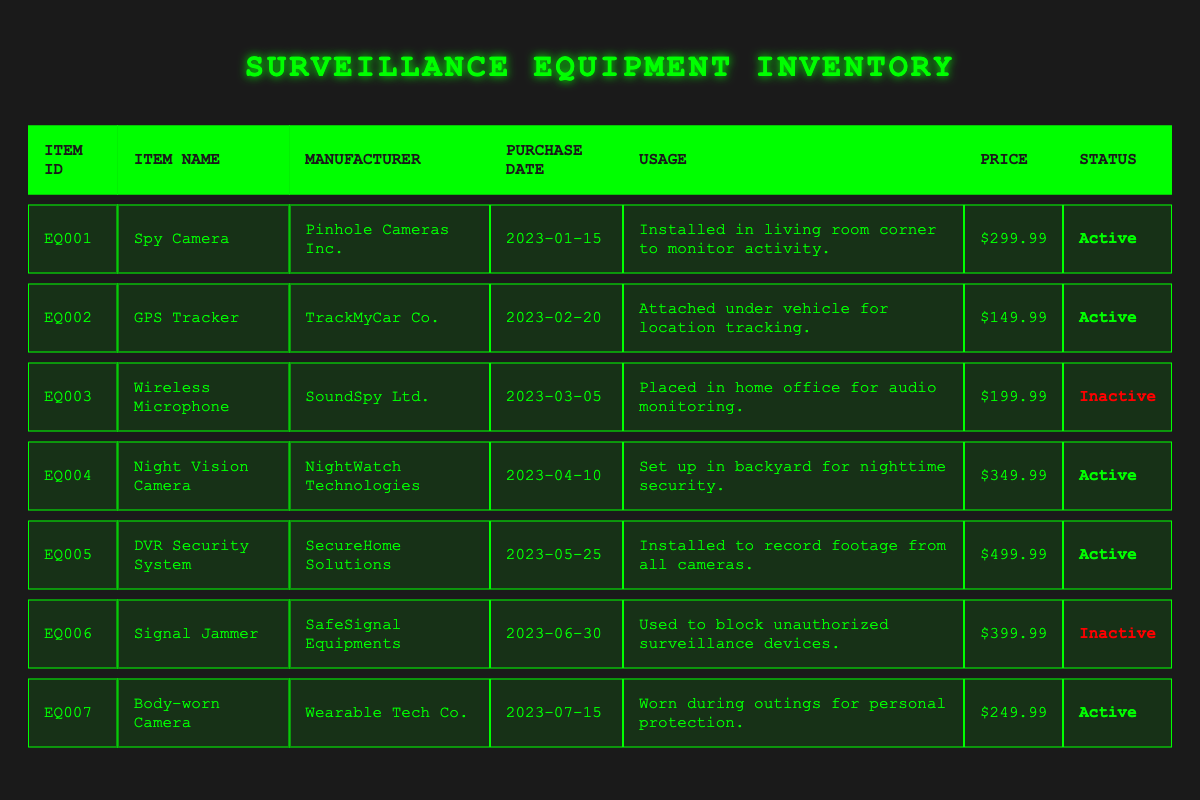What is the total number of active surveillance equipment items? By looking at the status column, we can see that the active items are: Spy Camera, GPS Tracker, Night Vision Camera, DVR Security System, and Body-worn Camera. There are 5 items in total that are marked as active.
Answer: 5 Which item is the most expensive and what is its price? The prices for each item are: Spy Camera ($299.99), GPS Tracker ($149.99), Wireless Microphone ($199.99), Night Vision Camera ($349.99), DVR Security System ($499.99), Signal Jammer ($399.99), and Body-worn Camera ($249.99). The DVR Security System has the highest price of $499.99.
Answer: DVR Security System, $499.99 Is the Wireless Microphone currently active? The status column shows that the Wireless Microphone is labeled as inactive.
Answer: No What is the average price of all surveillance equipment? The prices of the items are: $299.99, $149.99, $199.99, $349.99, $499.99, $399.99, and $249.99. Summing these gives a total of $2149.94, and dividing by the number of items (7) gives an average price of approximately $307.13.
Answer: $307.13 Are all items purchased from different manufacturers? Reviewing the manufacturers: Pinhole Cameras Inc., TrackMyCar Co., SoundSpy Ltd., NightWatch Technologies, SecureHome Solutions, SafeSignal Equipments, and Wearable Tech Co., we see that all items have unique manufacturers with no duplicates.
Answer: Yes Which piece of equipment has multiple uses listed in the table? Looking through the usage descriptions, each item has only one specific use listed, such as monitoring, tracking, or protecting. Therefore, none of the items have multiple uses mentioned in the table.
Answer: None How many items were purchased after April 2023? Checking the purchase dates, the items purchased after April 2023 are the DVR Security System (May 25, 2023), Signal Jammer (June 30, 2023), and Body-worn Camera (July 15, 2023). This totals to 3 items purchased after April 2023.
Answer: 3 What is the total cost of the inactive items? The inactive items are the Wireless Microphone ($199.99) and Signal Jammer ($399.99). Adding these gives a total cost of $199.99 + $399.99 = $599.98.
Answer: $599.98 Is there any surveillance equipment that is used outdoors? The usage descriptions indicate that the Night Vision Camera, which is set up in the backyard, clearly states an outdoor use. Therefore, there is at least one item that is used outdoors.
Answer: Yes 